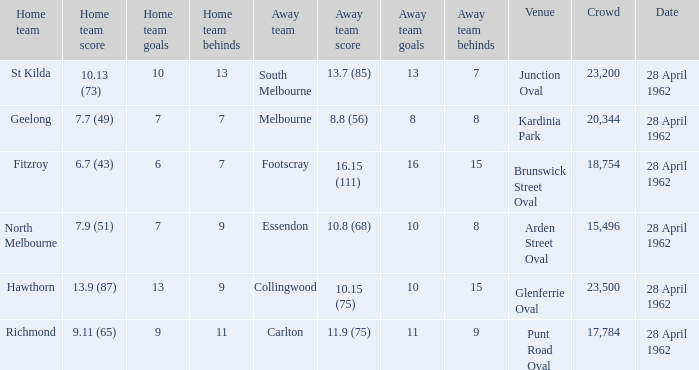What was the crowd size when there was a home team score of 10.13 (73)? 23200.0. 